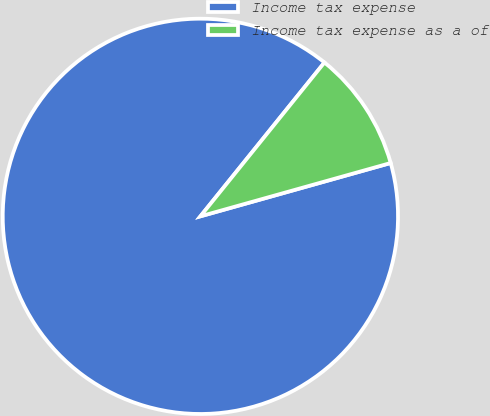<chart> <loc_0><loc_0><loc_500><loc_500><pie_chart><fcel>Income tax expense<fcel>Income tax expense as a of<nl><fcel>90.15%<fcel>9.85%<nl></chart> 